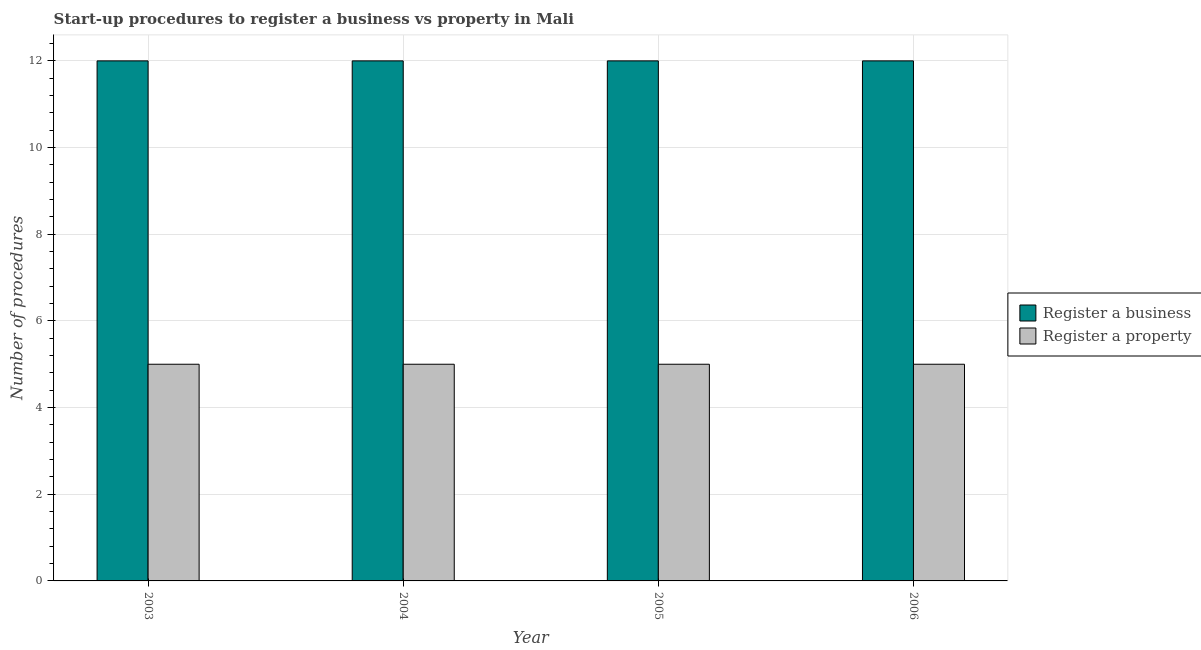Are the number of bars on each tick of the X-axis equal?
Provide a succinct answer. Yes. How many bars are there on the 3rd tick from the left?
Keep it short and to the point. 2. In how many cases, is the number of bars for a given year not equal to the number of legend labels?
Provide a succinct answer. 0. What is the number of procedures to register a business in 2003?
Make the answer very short. 12. Across all years, what is the maximum number of procedures to register a business?
Ensure brevity in your answer.  12. Across all years, what is the minimum number of procedures to register a business?
Offer a very short reply. 12. In which year was the number of procedures to register a property minimum?
Offer a very short reply. 2003. What is the total number of procedures to register a business in the graph?
Your answer should be very brief. 48. What is the average number of procedures to register a business per year?
Your answer should be compact. 12. In the year 2006, what is the difference between the number of procedures to register a property and number of procedures to register a business?
Ensure brevity in your answer.  0. Is the number of procedures to register a business in 2003 less than that in 2006?
Ensure brevity in your answer.  No. Is the difference between the number of procedures to register a business in 2003 and 2006 greater than the difference between the number of procedures to register a property in 2003 and 2006?
Offer a very short reply. No. What is the difference between the highest and the second highest number of procedures to register a business?
Provide a short and direct response. 0. Is the sum of the number of procedures to register a property in 2003 and 2004 greater than the maximum number of procedures to register a business across all years?
Give a very brief answer. Yes. What does the 1st bar from the left in 2004 represents?
Offer a very short reply. Register a business. What does the 2nd bar from the right in 2003 represents?
Offer a very short reply. Register a business. What is the difference between two consecutive major ticks on the Y-axis?
Keep it short and to the point. 2. Are the values on the major ticks of Y-axis written in scientific E-notation?
Make the answer very short. No. Does the graph contain any zero values?
Your response must be concise. No. Does the graph contain grids?
Offer a very short reply. Yes. Where does the legend appear in the graph?
Keep it short and to the point. Center right. How many legend labels are there?
Make the answer very short. 2. What is the title of the graph?
Your response must be concise. Start-up procedures to register a business vs property in Mali. Does "Goods" appear as one of the legend labels in the graph?
Your answer should be very brief. No. What is the label or title of the X-axis?
Give a very brief answer. Year. What is the label or title of the Y-axis?
Your answer should be compact. Number of procedures. What is the Number of procedures of Register a property in 2003?
Your response must be concise. 5. What is the Number of procedures in Register a business in 2005?
Your response must be concise. 12. What is the Number of procedures in Register a property in 2006?
Offer a very short reply. 5. Across all years, what is the minimum Number of procedures in Register a business?
Your answer should be very brief. 12. What is the total Number of procedures in Register a business in the graph?
Your answer should be very brief. 48. What is the difference between the Number of procedures of Register a property in 2003 and that in 2004?
Your answer should be very brief. 0. What is the difference between the Number of procedures of Register a business in 2003 and that in 2005?
Offer a terse response. 0. What is the difference between the Number of procedures in Register a property in 2003 and that in 2005?
Provide a short and direct response. 0. What is the difference between the Number of procedures in Register a business in 2003 and that in 2006?
Your answer should be compact. 0. What is the difference between the Number of procedures of Register a property in 2004 and that in 2005?
Give a very brief answer. 0. What is the difference between the Number of procedures in Register a business in 2004 and that in 2006?
Your answer should be very brief. 0. What is the difference between the Number of procedures in Register a property in 2004 and that in 2006?
Ensure brevity in your answer.  0. What is the difference between the Number of procedures of Register a business in 2005 and that in 2006?
Your answer should be very brief. 0. What is the difference between the Number of procedures of Register a property in 2005 and that in 2006?
Provide a succinct answer. 0. What is the difference between the Number of procedures in Register a business in 2003 and the Number of procedures in Register a property in 2004?
Keep it short and to the point. 7. What is the difference between the Number of procedures of Register a business in 2005 and the Number of procedures of Register a property in 2006?
Your answer should be very brief. 7. What is the average Number of procedures of Register a property per year?
Offer a very short reply. 5. In the year 2004, what is the difference between the Number of procedures in Register a business and Number of procedures in Register a property?
Your response must be concise. 7. In the year 2006, what is the difference between the Number of procedures of Register a business and Number of procedures of Register a property?
Provide a short and direct response. 7. What is the ratio of the Number of procedures of Register a property in 2003 to that in 2004?
Offer a terse response. 1. What is the ratio of the Number of procedures in Register a property in 2003 to that in 2005?
Provide a short and direct response. 1. What is the ratio of the Number of procedures of Register a business in 2003 to that in 2006?
Provide a succinct answer. 1. What is the ratio of the Number of procedures of Register a property in 2004 to that in 2005?
Ensure brevity in your answer.  1. What is the ratio of the Number of procedures in Register a business in 2004 to that in 2006?
Provide a short and direct response. 1. What is the ratio of the Number of procedures in Register a property in 2004 to that in 2006?
Your answer should be very brief. 1. What is the ratio of the Number of procedures in Register a business in 2005 to that in 2006?
Your answer should be compact. 1. What is the difference between the highest and the second highest Number of procedures in Register a business?
Your answer should be compact. 0. 